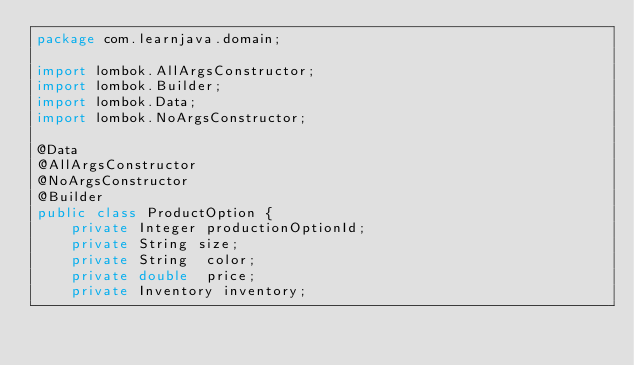<code> <loc_0><loc_0><loc_500><loc_500><_Java_>package com.learnjava.domain;

import lombok.AllArgsConstructor;
import lombok.Builder;
import lombok.Data;
import lombok.NoArgsConstructor;

@Data
@AllArgsConstructor
@NoArgsConstructor
@Builder
public class ProductOption {
    private Integer productionOptionId;
    private String size;
    private String  color;
    private double  price;
    private Inventory inventory;
</code> 